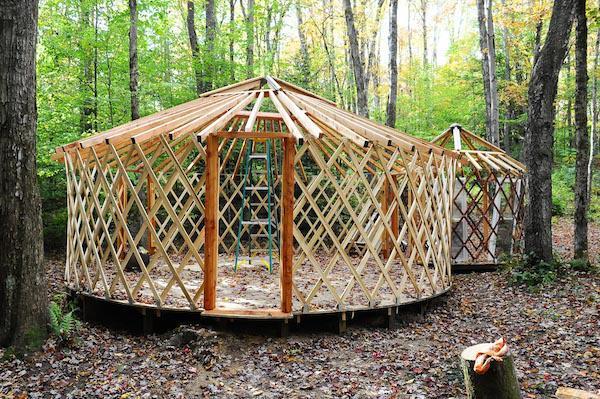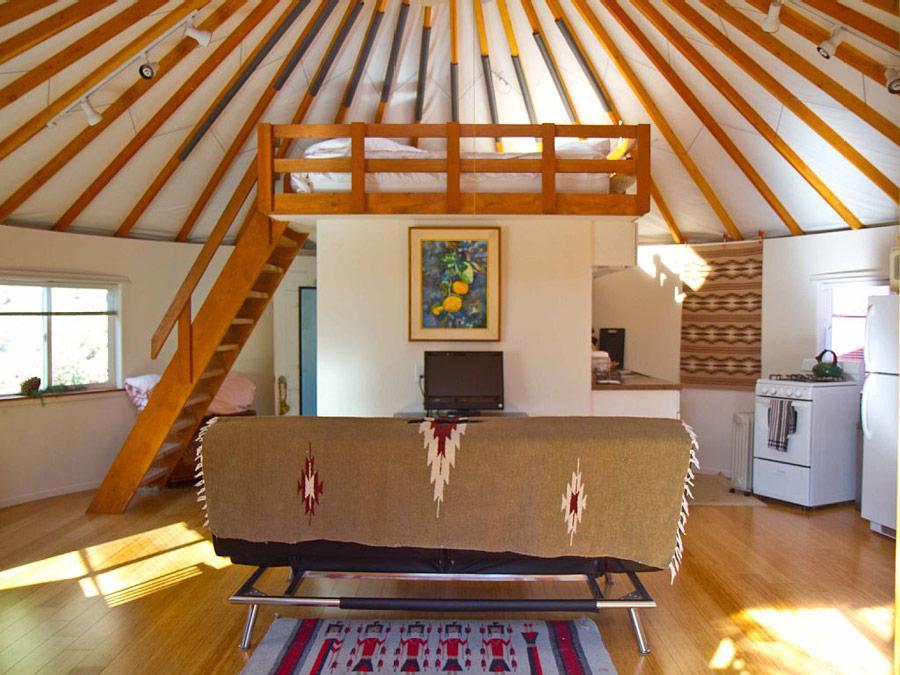The first image is the image on the left, the second image is the image on the right. Considering the images on both sides, is "In the right image there is a staircase on the left leading up right towards the center." valid? Answer yes or no. Yes. 